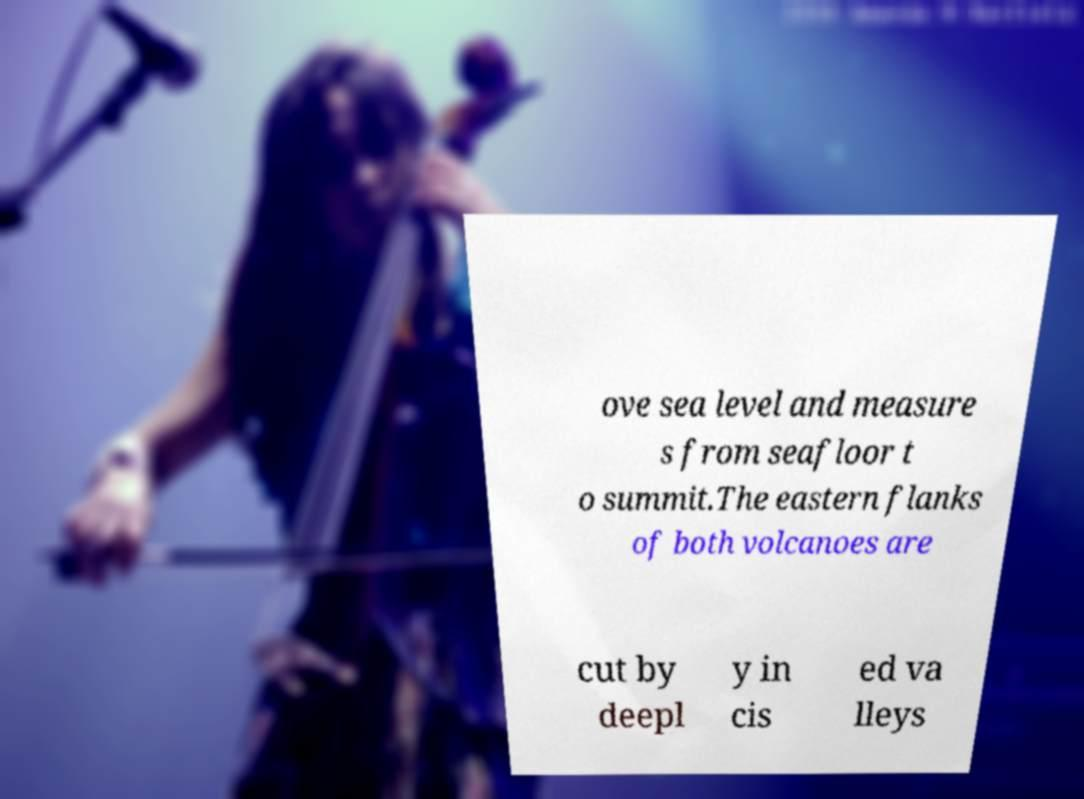Can you read and provide the text displayed in the image?This photo seems to have some interesting text. Can you extract and type it out for me? ove sea level and measure s from seafloor t o summit.The eastern flanks of both volcanoes are cut by deepl y in cis ed va lleys 